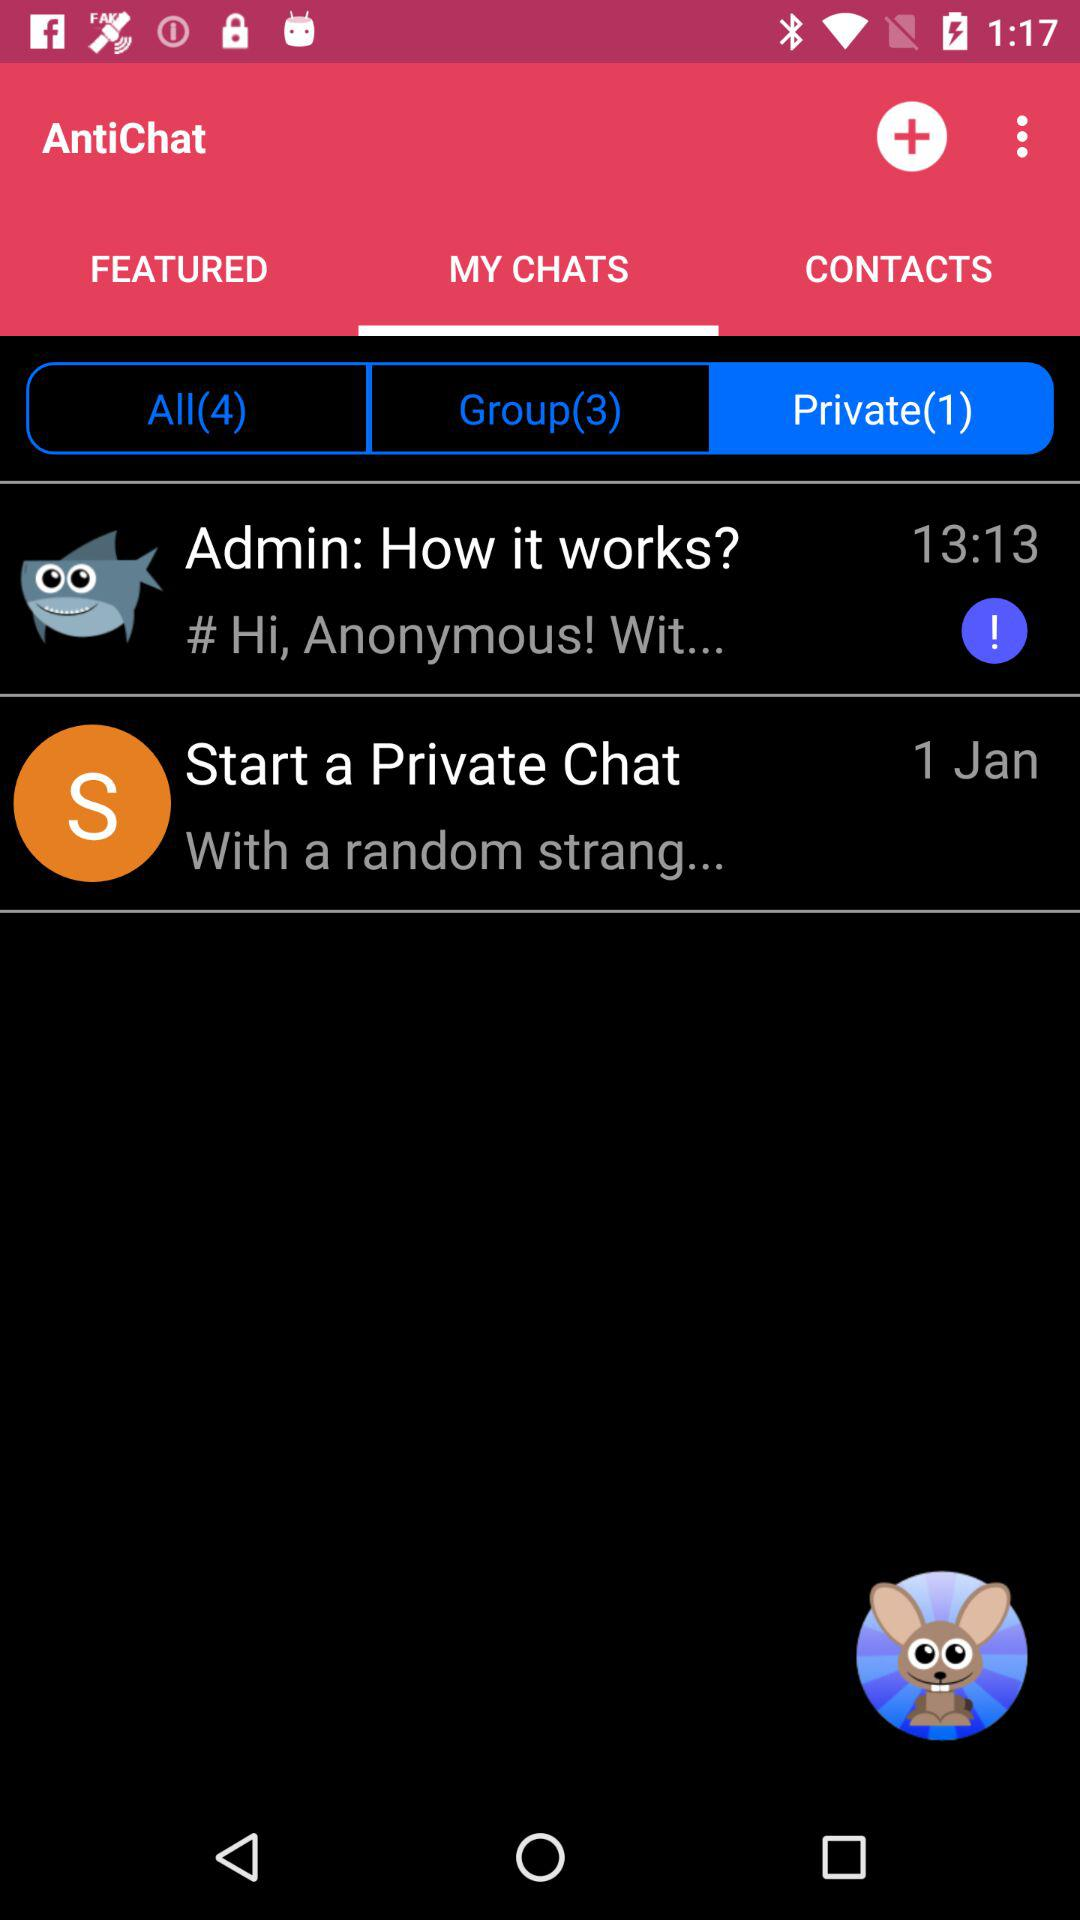How many group chats are there? There are 3 group chats. 